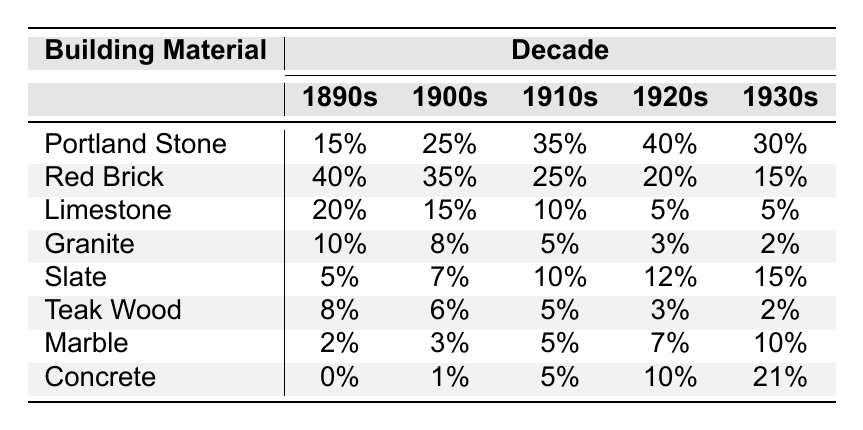What building material had the highest usage in the 1910s? By looking at the 1910s column in the table, Portland Stone shows the highest percentage at 35%.
Answer: Portland Stone In which decade did Red Brick usage hit its lowest point? The 1930s column indicates Red Brick usage is at its lowest at 15%.
Answer: 1930s What is the total percentage usage of Limestone over all decades? Adding Limestone percentages for all decades: 20 + 15 + 10 + 5 + 5 = 55%.
Answer: 55% Which material saw the largest increase in usage from the 1900s to the 1920s? Portland Stone usage increased from 25% in the 1900s to 40% in the 1920s, a gain of 15%. This is the highest increase compared to other materials.
Answer: Portland Stone Is Concrete used more in the 1930s than in the 1890s? Yes, in the 1930s Concrete usage is at 21%, whereas it was 0% in the 1890s.
Answer: Yes What is the average percentage usage of Slate across all decades? The average is calculated by summing Slate usage: (5 + 7 + 10 + 12 + 15) = 49, then dividing by 5 gives 49/5 = 9.8%.
Answer: 9.8% Which building material had the most consistent usage across the decades? Red Brick shows a gradual decrease but stays relatively high across the decades, with values of 40%, 35%, 25%, 20%, and 15%. This trend is less volatile than others indicating consistency.
Answer: Red Brick Did Granite usage ever exceed 10% in the 1930s? No, in the 1930s, Granite usage is only 2%, which is significantly lower than 10%.
Answer: No What is the difference in usage of Teak Wood between the 1890s and 1930s? In the 1890s, Teak Wood usage is 8% and in the 1930s, it dropped to 2%. The difference is 8% - 2% = 6%.
Answer: 6% Which material had the greatest increase in usage from the 1900s to the 1930s? Concrete increased from 1% in the 1900s to 21% in the 1930s, which is an increase of 20%. No other material had such a significant increase during this period.
Answer: Concrete 